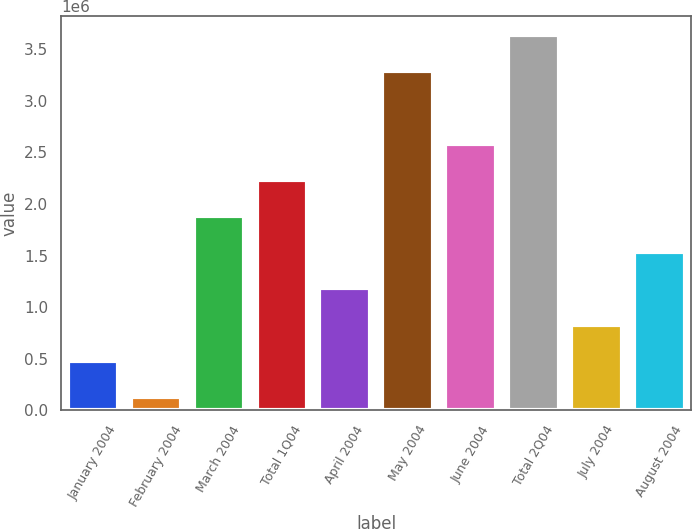<chart> <loc_0><loc_0><loc_500><loc_500><bar_chart><fcel>January 2004<fcel>February 2004<fcel>March 2004<fcel>Total 1Q04<fcel>April 2004<fcel>May 2004<fcel>June 2004<fcel>Total 2Q04<fcel>July 2004<fcel>August 2004<nl><fcel>479700<fcel>129000<fcel>1.8825e+06<fcel>2.2332e+06<fcel>1.1811e+06<fcel>3.2853e+06<fcel>2.5839e+06<fcel>3.636e+06<fcel>830400<fcel>1.5318e+06<nl></chart> 